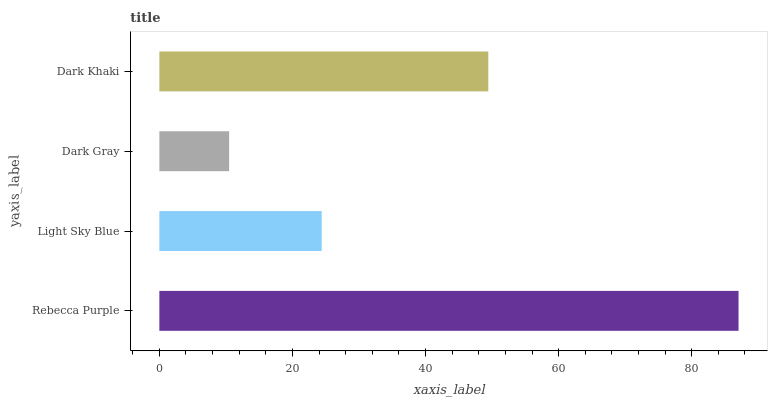Is Dark Gray the minimum?
Answer yes or no. Yes. Is Rebecca Purple the maximum?
Answer yes or no. Yes. Is Light Sky Blue the minimum?
Answer yes or no. No. Is Light Sky Blue the maximum?
Answer yes or no. No. Is Rebecca Purple greater than Light Sky Blue?
Answer yes or no. Yes. Is Light Sky Blue less than Rebecca Purple?
Answer yes or no. Yes. Is Light Sky Blue greater than Rebecca Purple?
Answer yes or no. No. Is Rebecca Purple less than Light Sky Blue?
Answer yes or no. No. Is Dark Khaki the high median?
Answer yes or no. Yes. Is Light Sky Blue the low median?
Answer yes or no. Yes. Is Dark Gray the high median?
Answer yes or no. No. Is Dark Khaki the low median?
Answer yes or no. No. 